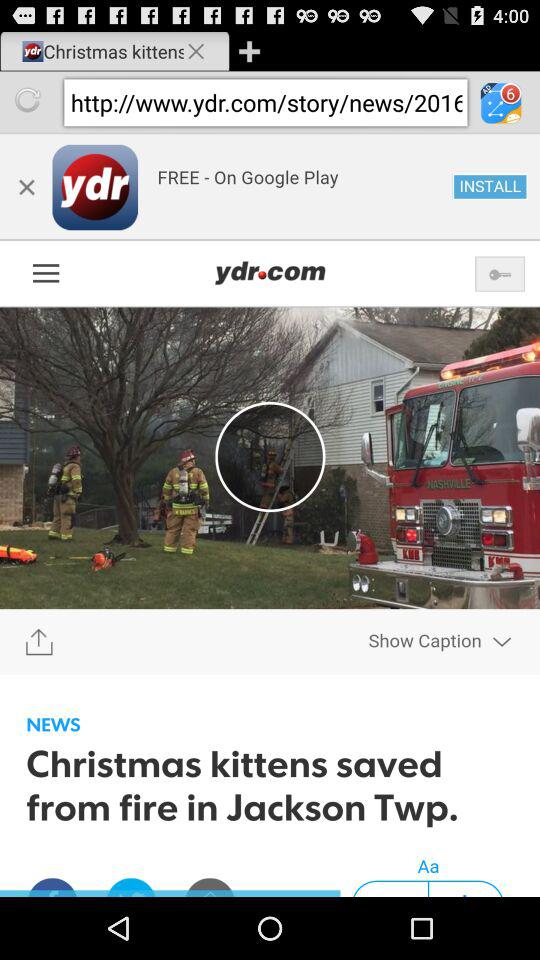What is the name of the application? The name of the application is "York Daily Record eNewspaper". 